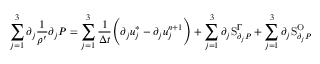Convert formula to latex. <formula><loc_0><loc_0><loc_500><loc_500>\sum _ { j = 1 } ^ { 3 } \partial _ { j } \frac { 1 } { \rho ^ { \prime } } \partial _ { j } P = \sum _ { j = 1 } ^ { 3 } \frac { 1 } { \Delta t } \left ( \partial _ { j } u _ { j } ^ { * } - \partial _ { j } u _ { j } ^ { n + 1 } \right ) + \sum _ { j = 1 } ^ { 3 } \partial _ { j } S _ { \partial _ { j } P } ^ { \Gamma } + \sum _ { j = 1 } ^ { 3 } \partial _ { j } S _ { \partial _ { j } P } ^ { O }</formula> 